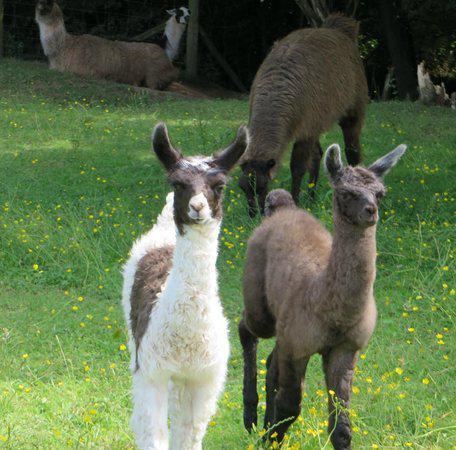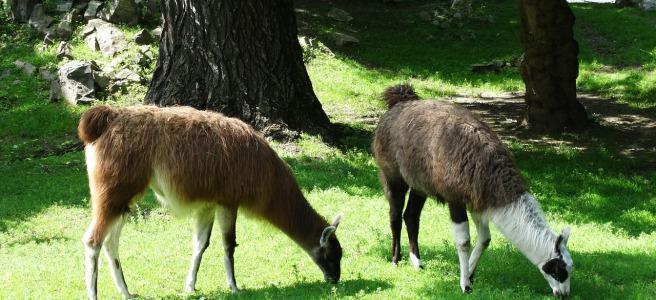The first image is the image on the left, the second image is the image on the right. Analyze the images presented: Is the assertion "The animals in the image on the right are surrounding by a fence." valid? Answer yes or no. No. The first image is the image on the left, the second image is the image on the right. Given the left and right images, does the statement "Each image shows a pair of llamas in the foreground, and at least one pair includes a white llama and a brownish llama." hold true? Answer yes or no. Yes. 